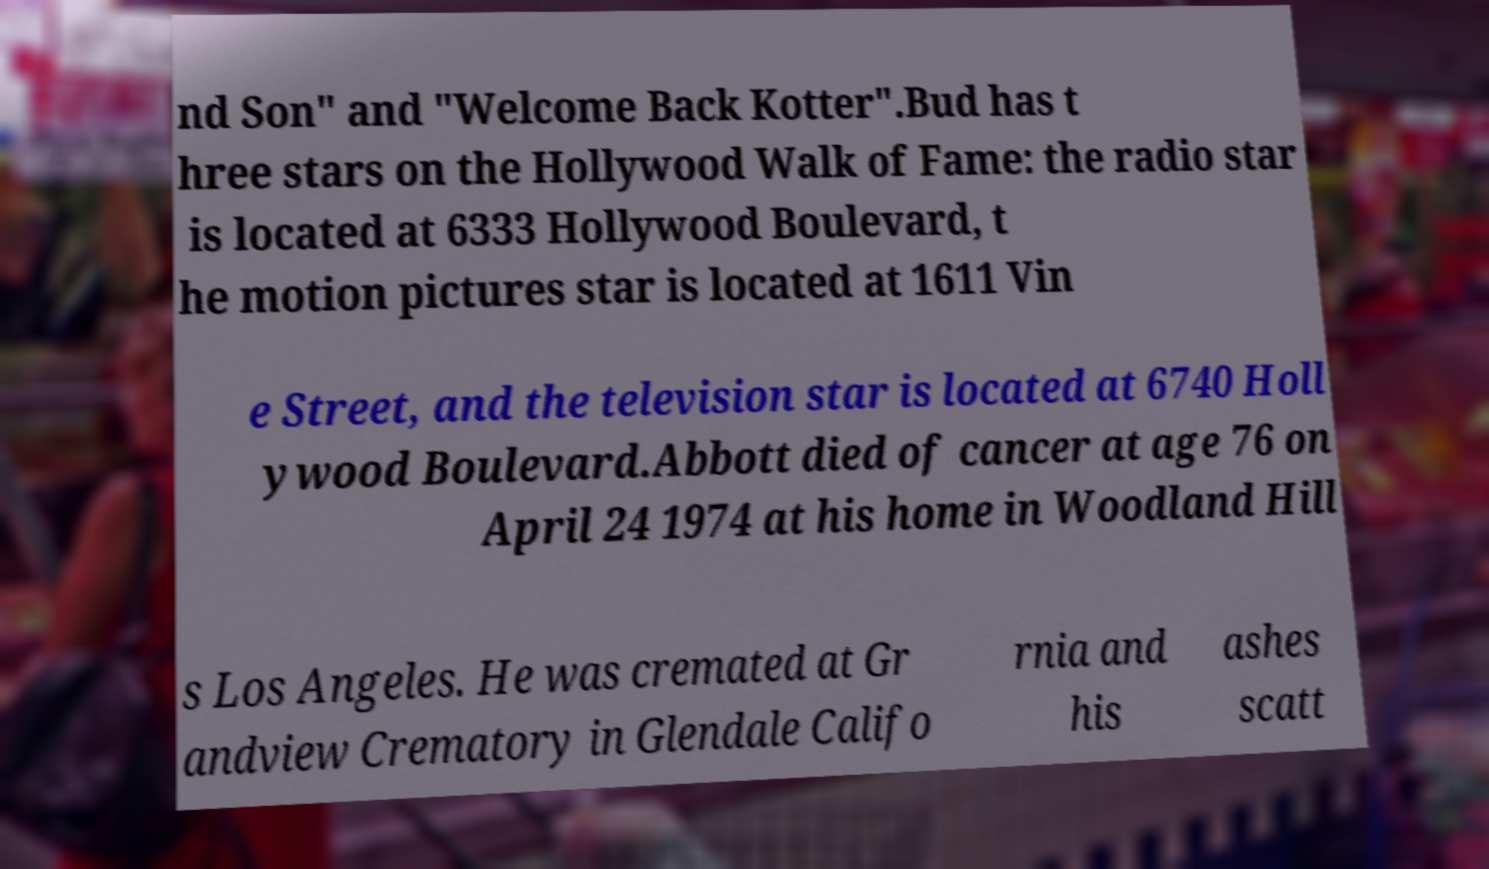Could you assist in decoding the text presented in this image and type it out clearly? nd Son" and "Welcome Back Kotter".Bud has t hree stars on the Hollywood Walk of Fame: the radio star is located at 6333 Hollywood Boulevard, t he motion pictures star is located at 1611 Vin e Street, and the television star is located at 6740 Holl ywood Boulevard.Abbott died of cancer at age 76 on April 24 1974 at his home in Woodland Hill s Los Angeles. He was cremated at Gr andview Crematory in Glendale Califo rnia and his ashes scatt 